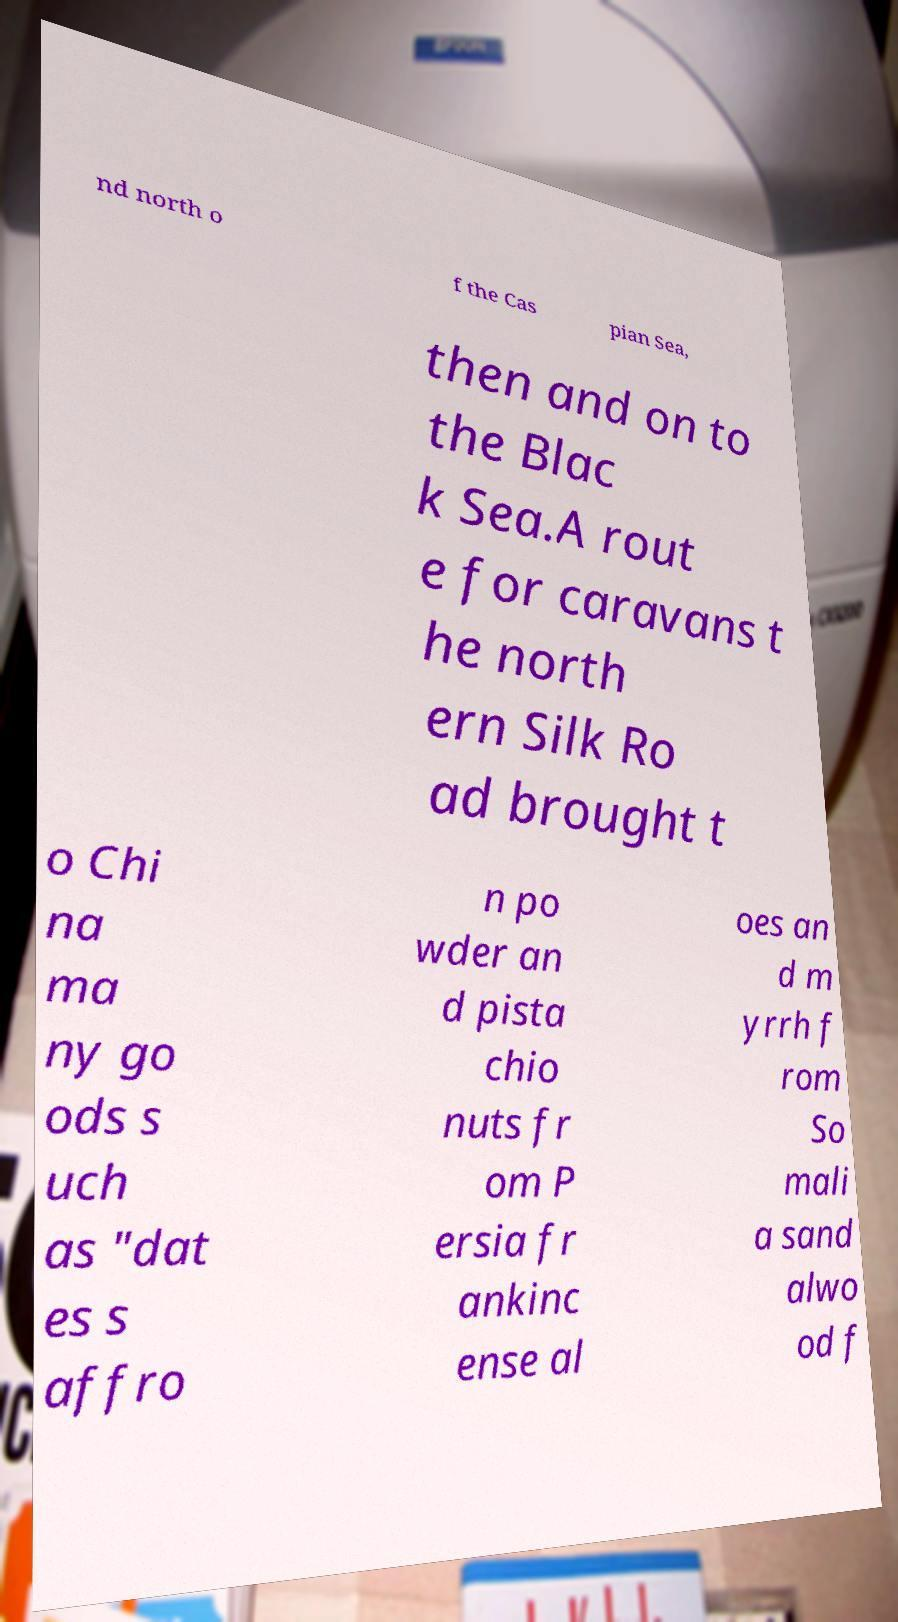What messages or text are displayed in this image? I need them in a readable, typed format. nd north o f the Cas pian Sea, then and on to the Blac k Sea.A rout e for caravans t he north ern Silk Ro ad brought t o Chi na ma ny go ods s uch as "dat es s affro n po wder an d pista chio nuts fr om P ersia fr ankinc ense al oes an d m yrrh f rom So mali a sand alwo od f 